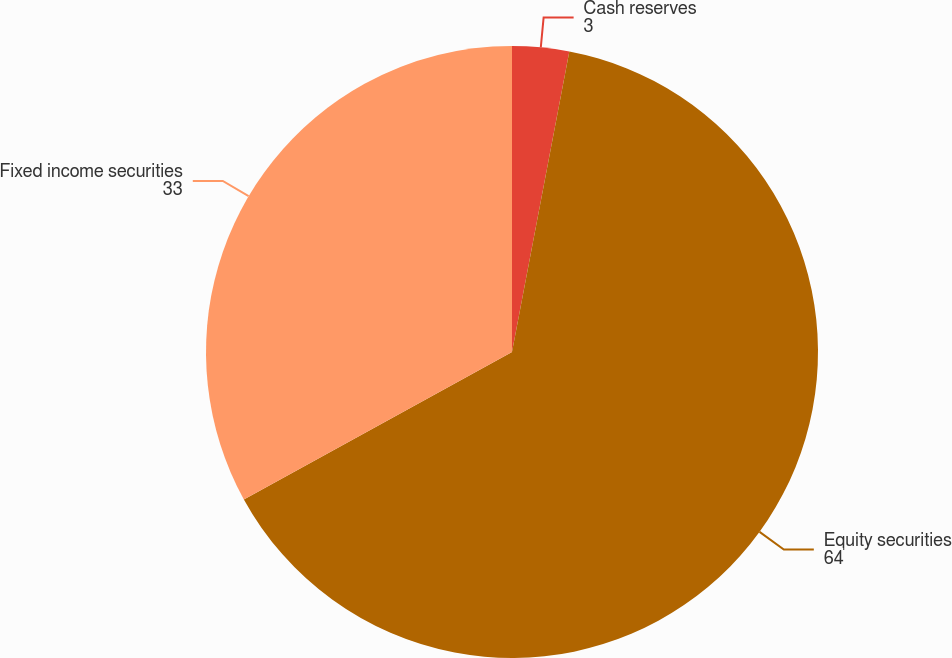Convert chart. <chart><loc_0><loc_0><loc_500><loc_500><pie_chart><fcel>Cash reserves<fcel>Equity securities<fcel>Fixed income securities<nl><fcel>3.0%<fcel>64.0%<fcel>33.0%<nl></chart> 